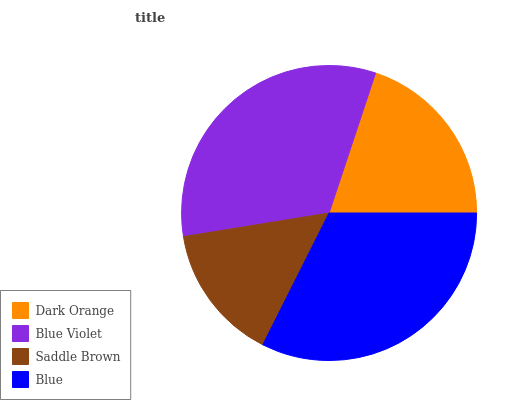Is Saddle Brown the minimum?
Answer yes or no. Yes. Is Blue Violet the maximum?
Answer yes or no. Yes. Is Blue Violet the minimum?
Answer yes or no. No. Is Saddle Brown the maximum?
Answer yes or no. No. Is Blue Violet greater than Saddle Brown?
Answer yes or no. Yes. Is Saddle Brown less than Blue Violet?
Answer yes or no. Yes. Is Saddle Brown greater than Blue Violet?
Answer yes or no. No. Is Blue Violet less than Saddle Brown?
Answer yes or no. No. Is Blue the high median?
Answer yes or no. Yes. Is Dark Orange the low median?
Answer yes or no. Yes. Is Blue Violet the high median?
Answer yes or no. No. Is Blue the low median?
Answer yes or no. No. 